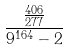<formula> <loc_0><loc_0><loc_500><loc_500>\frac { \frac { 4 0 6 } { 2 7 7 } } { 9 ^ { 1 6 4 } - 2 }</formula> 